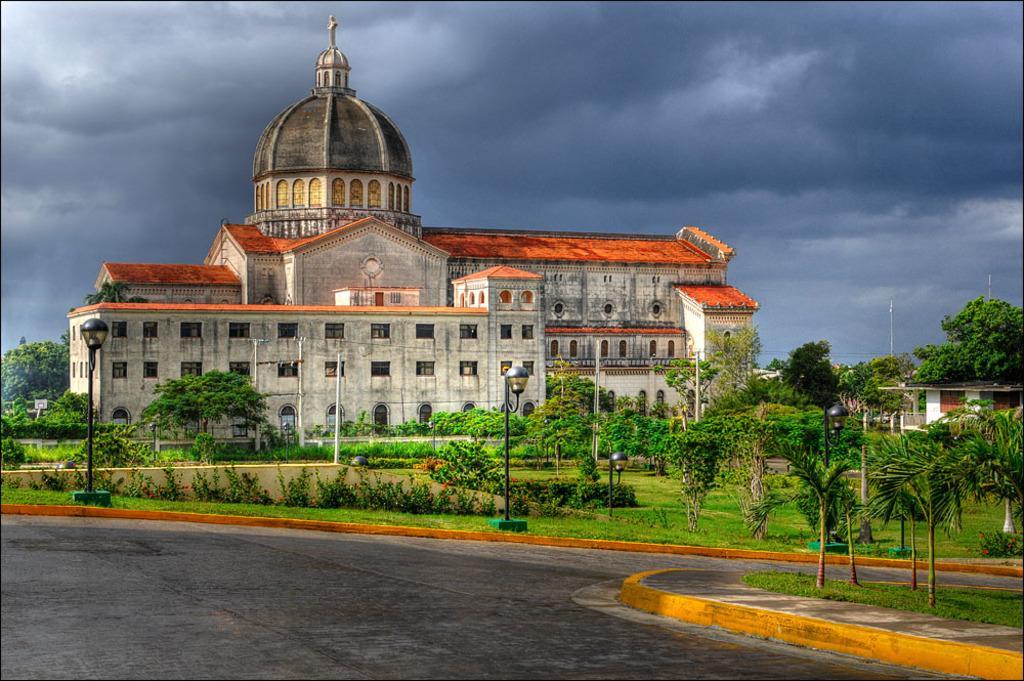How would you summarize this image in a sentence or two? In this image we can see a building. There are many trees and plants in the image. We can see the clouds in the sky. There is a road in the image. 